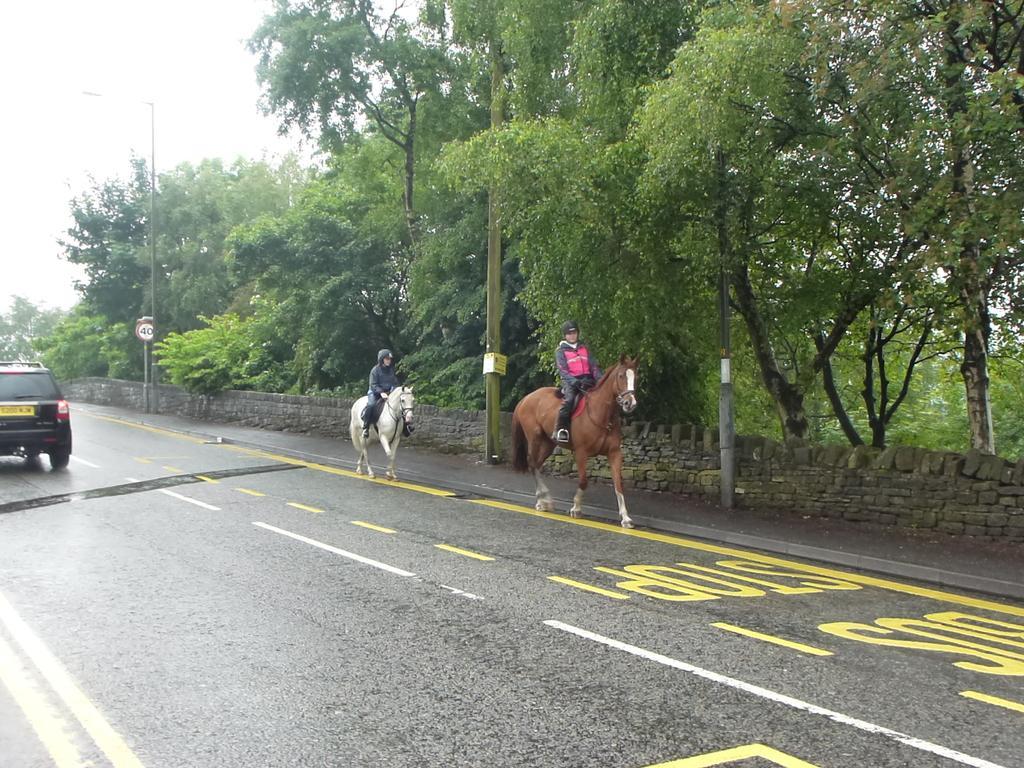How would you summarize this image in a sentence or two? In this picture we can see two horses and a car on the road with two persons sitting on horses, wall, trees and in the background we can see trees. 